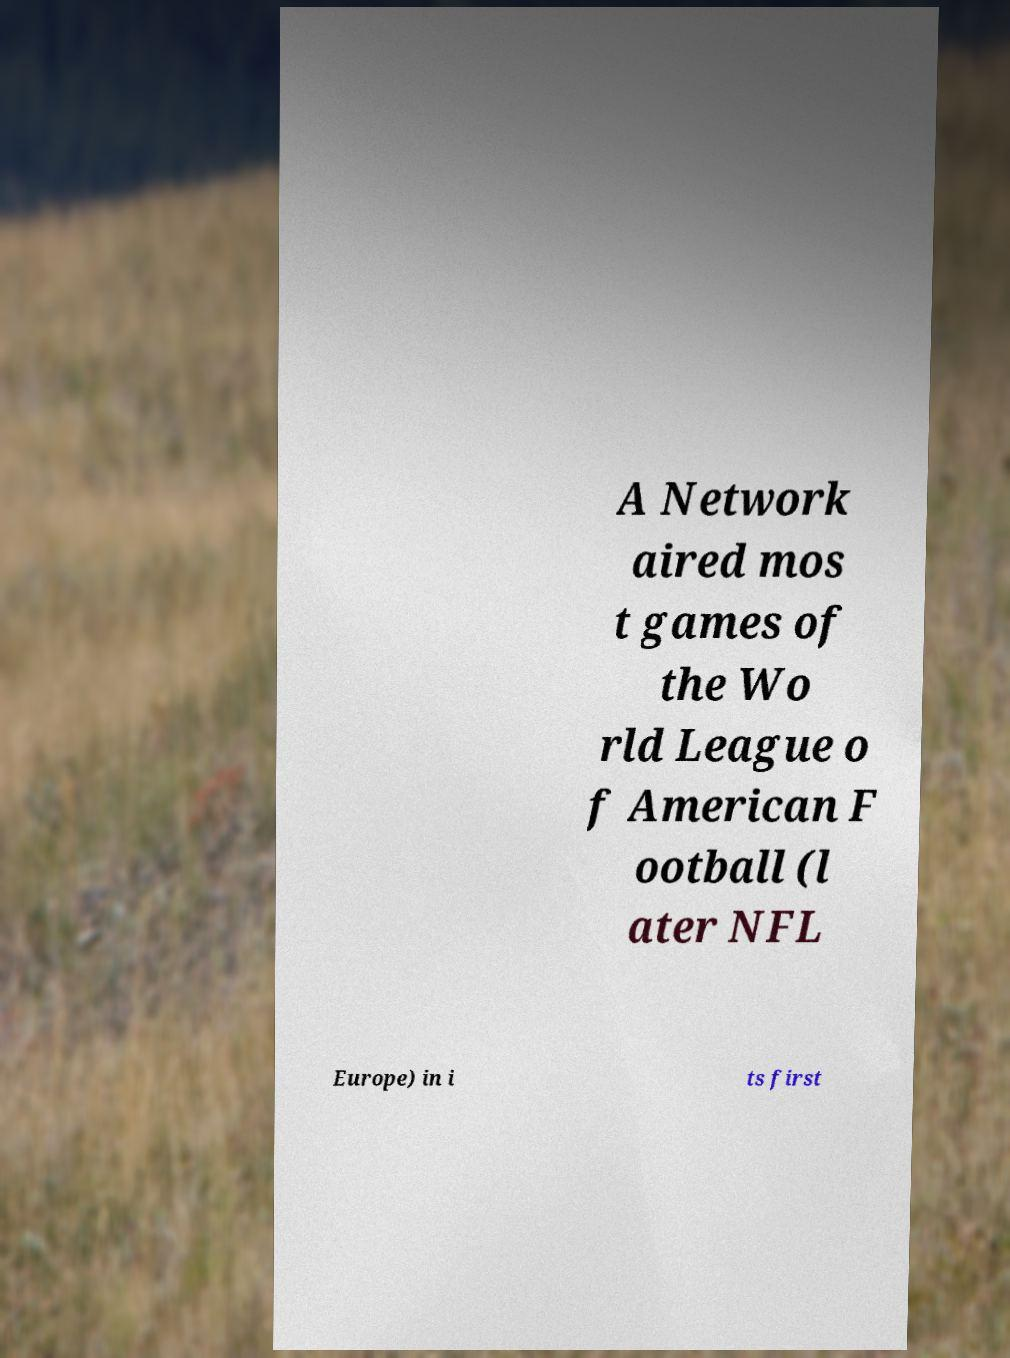What messages or text are displayed in this image? I need them in a readable, typed format. A Network aired mos t games of the Wo rld League o f American F ootball (l ater NFL Europe) in i ts first 